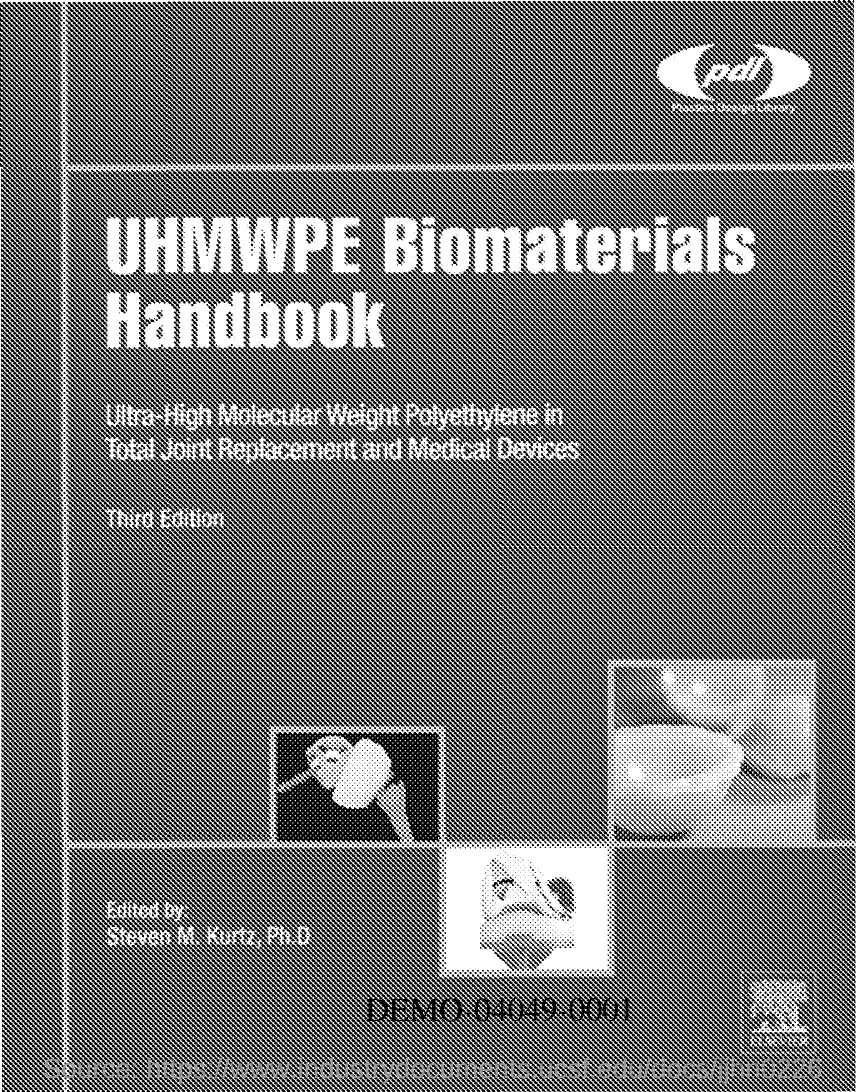What is the name of the Handbook?
Give a very brief answer. UHMWPE BIOMATERIALS HANDBOOK. 